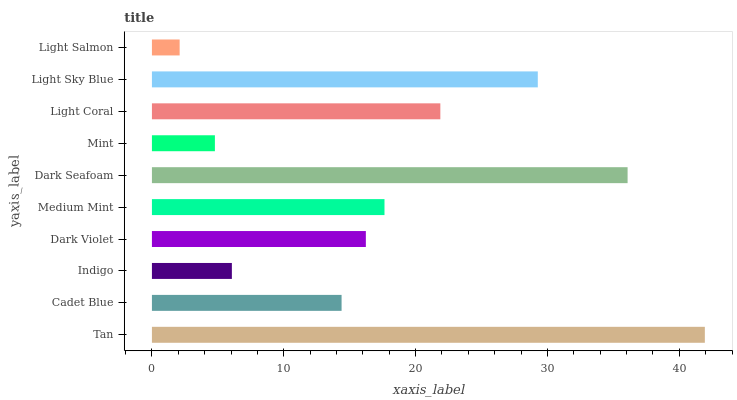Is Light Salmon the minimum?
Answer yes or no. Yes. Is Tan the maximum?
Answer yes or no. Yes. Is Cadet Blue the minimum?
Answer yes or no. No. Is Cadet Blue the maximum?
Answer yes or no. No. Is Tan greater than Cadet Blue?
Answer yes or no. Yes. Is Cadet Blue less than Tan?
Answer yes or no. Yes. Is Cadet Blue greater than Tan?
Answer yes or no. No. Is Tan less than Cadet Blue?
Answer yes or no. No. Is Medium Mint the high median?
Answer yes or no. Yes. Is Dark Violet the low median?
Answer yes or no. Yes. Is Mint the high median?
Answer yes or no. No. Is Cadet Blue the low median?
Answer yes or no. No. 